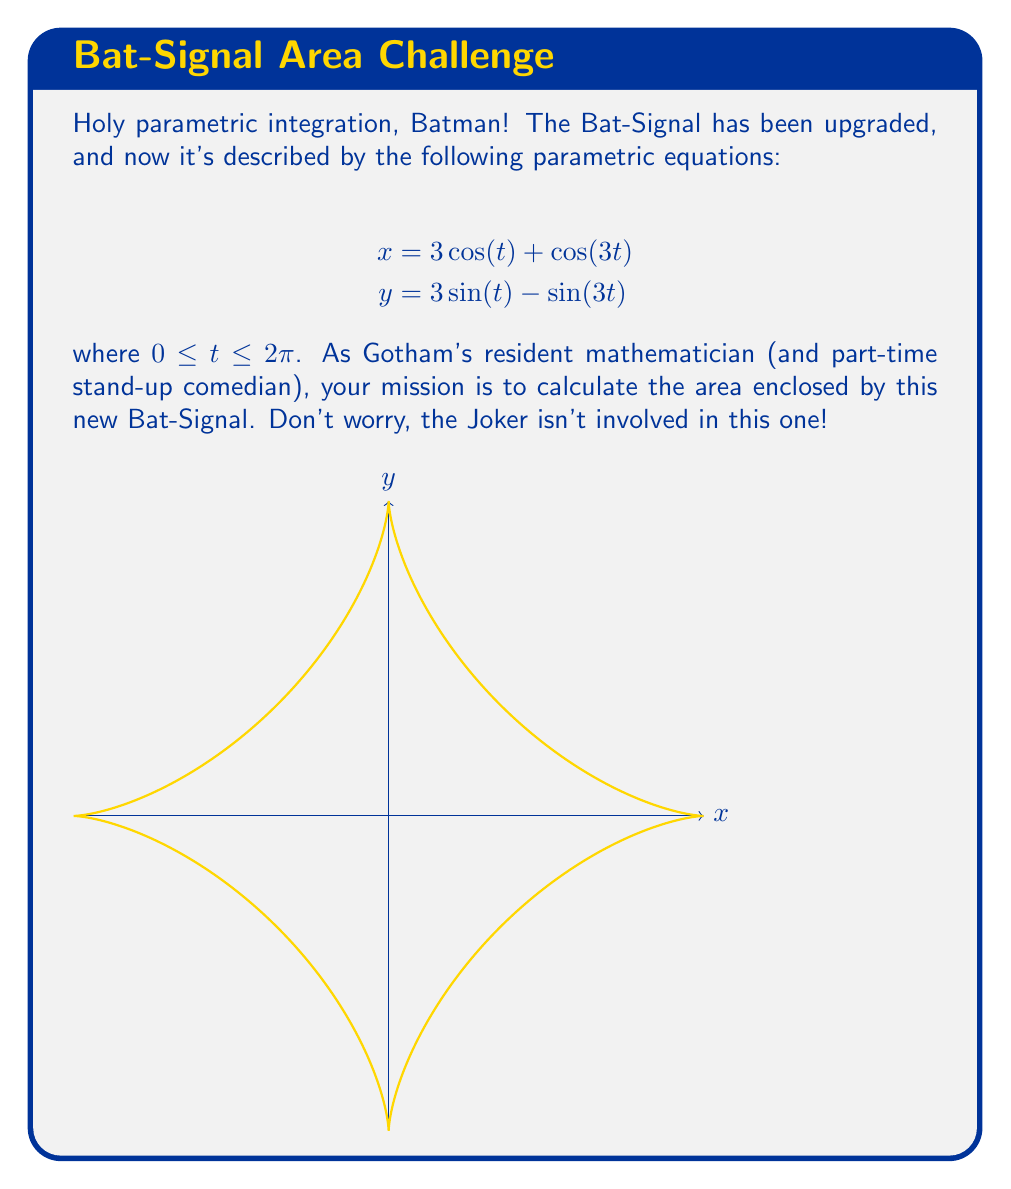What is the answer to this math problem? Alright, crime-fighting mathematicians, let's solve this puzzle faster than Batman can say "I'm Batman!"

1) To find the area enclosed by a parametric curve, we can use the formula:

   $$A = \frac{1}{2} \int_{0}^{2\pi} [x(t)\frac{dy}{dt} - y(t)\frac{dx}{dt}] dt$$

2) First, let's calculate $\frac{dx}{dt}$ and $\frac{dy}{dt}$:
   
   $$\frac{dx}{dt} = -3\sin(t) - 3\sin(3t)$$
   $$\frac{dy}{dt} = 3\cos(t) - 3\cos(3t)$$

3) Now, let's substitute these into our area formula:

   $$A = \frac{1}{2} \int_{0}^{2\pi} [(3\cos(t) + \cos(3t))(3\cos(t) - 3\cos(3t)) - (3\sin(t) - \sin(3t))(-3\sin(t) - 3\sin(3t))] dt$$

4) Expand this expression:

   $$A = \frac{1}{2} \int_{0}^{2\pi} [9\cos^2(t) - 3\cos(t)\cos(3t) + 3\cos(t)\cos(3t) - 3\cos^2(3t) + 9\sin^2(t) + 3\sin(t)\sin(3t) - 3\sin(t)\sin(3t) + 3\sin^2(3t)] dt$$

5) Simplify:

   $$A = \frac{1}{2} \int_{0}^{2\pi} [9\cos^2(t) + 9\sin^2(t) - 3\cos^2(3t) + 3\sin^2(3t)] dt$$

6) Use the trigonometric identities $\cos^2(t) + \sin^2(t) = 1$ and $\cos^2(3t) + \sin^2(3t) = 1$:

   $$A = \frac{1}{2} \int_{0}^{2\pi} [9 - 3] dt = 3 \int_{0}^{2\pi} dt = 3 \cdot 2\pi = 6\pi$$

And there you have it! The area of our new Bat-Signal, ready to shine over Gotham City!
Answer: $6\pi$ square units 